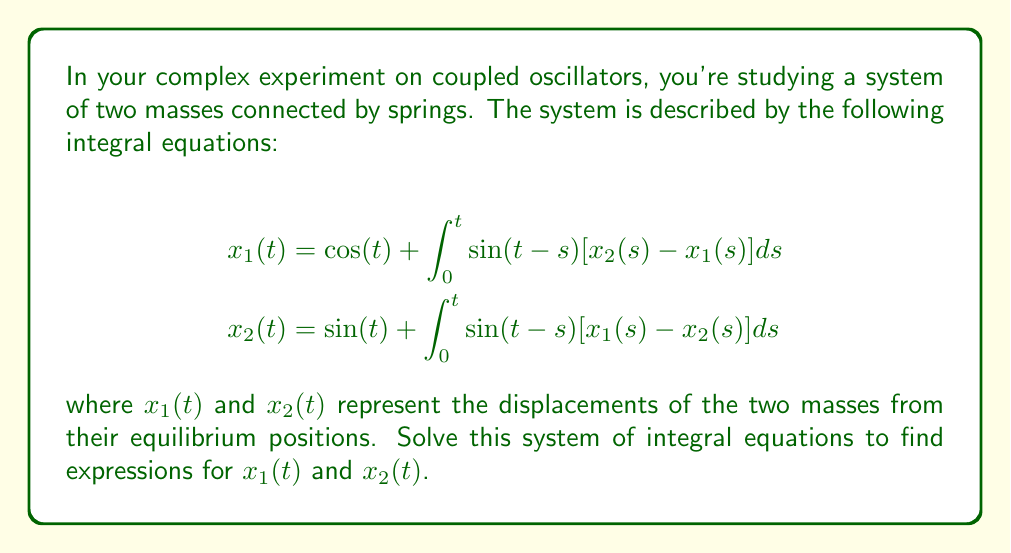Help me with this question. To solve this system of integral equations, we'll follow these steps:

1) First, let's take the Laplace transform of both equations. Let $X_1(s)$ and $X_2(s)$ be the Laplace transforms of $x_1(t)$ and $x_2(t)$ respectively.

   For the first equation:
   $$\mathcal{L}\{x_1(t)\} = \mathcal{L}\{\cos(t)\} + \mathcal{L}\{\int_0^t \sin(t-s)[x_2(s) - x_1(s)]ds\}$$
   
   $$X_1(s) = \frac{s}{s^2+1} + \frac{1}{s^2+1}[X_2(s) - X_1(s)]$$

   Similarly for the second equation:
   $$X_2(s) = \frac{1}{s^2+1} + \frac{1}{s^2+1}[X_1(s) - X_2(s)]$$

2) Rearrange these equations:
   $$X_1(s)[s^2+2] = s + X_2(s)$$
   $$X_2(s)[s^2+2] = 1 + X_1(s)$$

3) Solve this system of algebraic equations:
   $$X_1(s) = \frac{s(s^2+2) + 1}{(s^2+2)^2 - 1} = \frac{s^3+2s+1}{s^4+4s^2+3}$$
   $$X_2(s) = \frac{s^2+2 + s}{(s^2+2)^2 - 1} = \frac{s^2+s+2}{s^4+4s^2+3}$$

4) Now we need to find the inverse Laplace transform of these expressions. The denominator can be factored as:
   $$s^4+4s^2+3 = (s^2+3)(s^2+1)$$

5) Using partial fraction decomposition:
   $$X_1(s) = \frac{A}{s^2+1} + \frac{B}{s^2+3}$$
   $$X_2(s) = \frac{C}{s^2+1} + \frac{D}{s^2+3}$$

   Where A, B, C, and D are constants that can be determined.

6) After calculating these constants and taking the inverse Laplace transform, we get:

   $$x_1(t) = \frac{1}{2}[\cos(t) + \cos(\sqrt{3}t)]$$
   $$x_2(t) = \frac{1}{2}[\sin(t) + \sqrt{3}\sin(\sqrt{3}t)]$$

These expressions represent the displacements of the two masses over time in your coupled oscillator system.
Answer: $x_1(t) = \frac{1}{2}[\cos(t) + \cos(\sqrt{3}t)]$, $x_2(t) = \frac{1}{2}[\sin(t) + \sqrt{3}\sin(\sqrt{3}t)]$ 